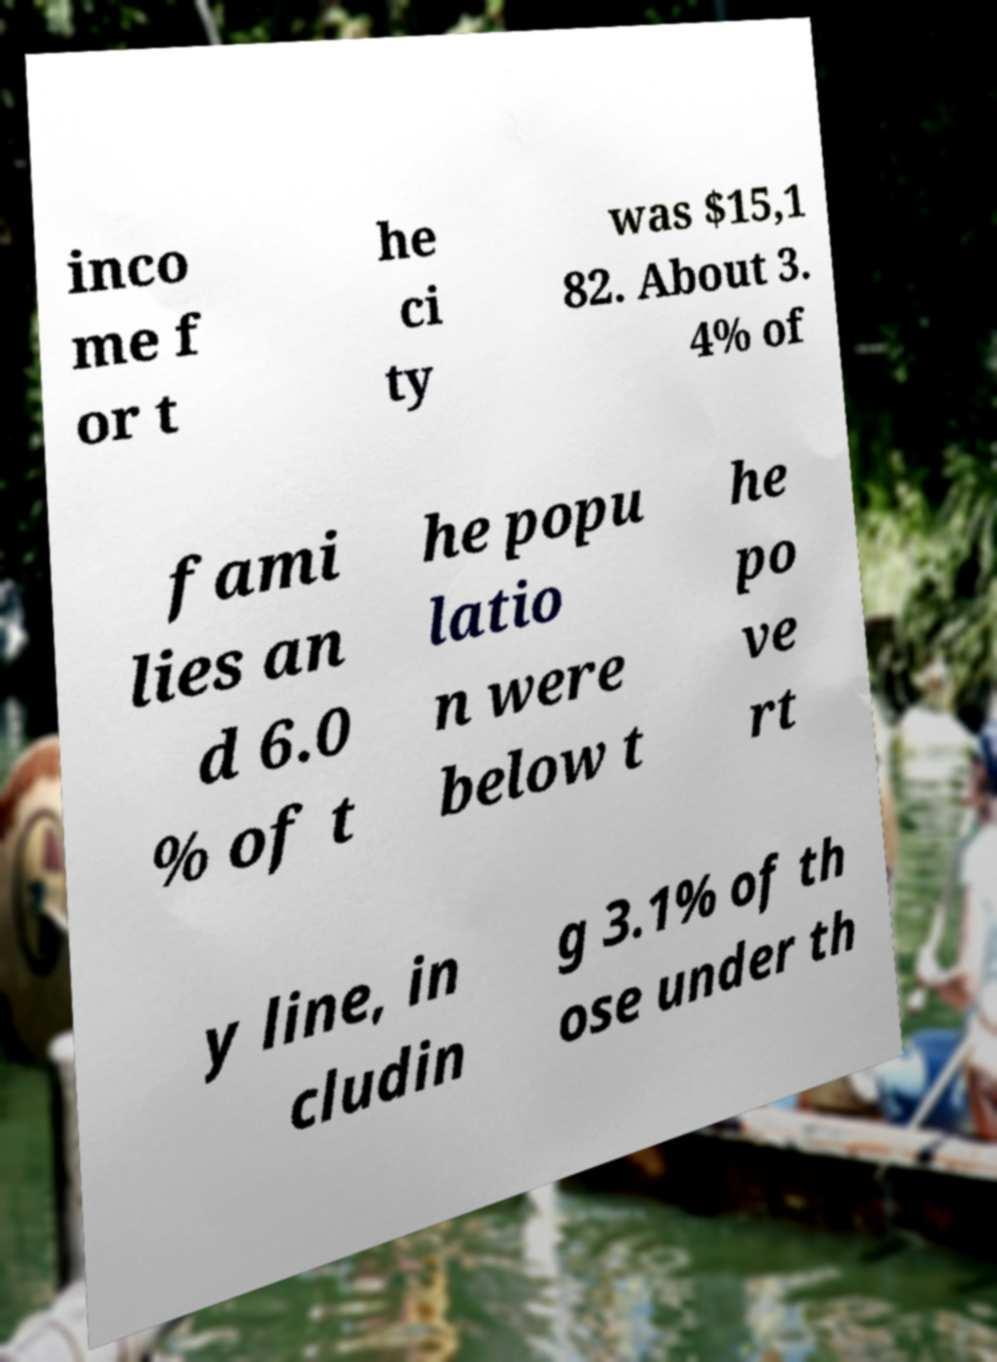Could you extract and type out the text from this image? inco me f or t he ci ty was $15,1 82. About 3. 4% of fami lies an d 6.0 % of t he popu latio n were below t he po ve rt y line, in cludin g 3.1% of th ose under th 